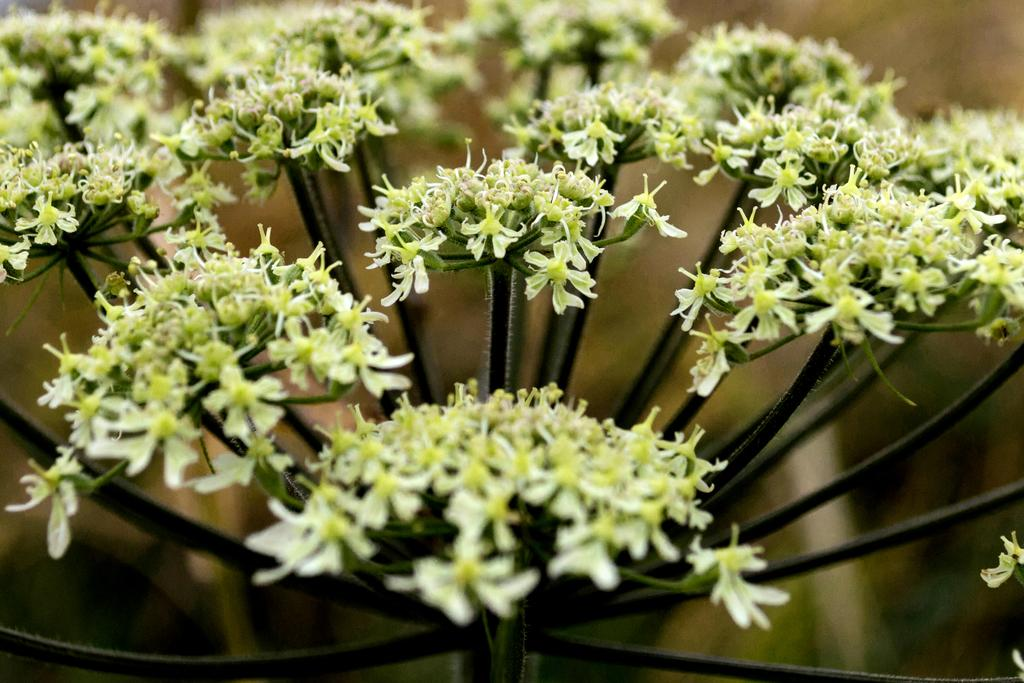What is present in the image? There are flowers in the image. Where are the flowers located? The flowers are on a plant. Can you describe the background of the image? The background of the image is blurred. How many silver ladybugs can be seen on the flowers in the image? There are no ladybugs, silver or otherwise, present on the flowers in the image. 